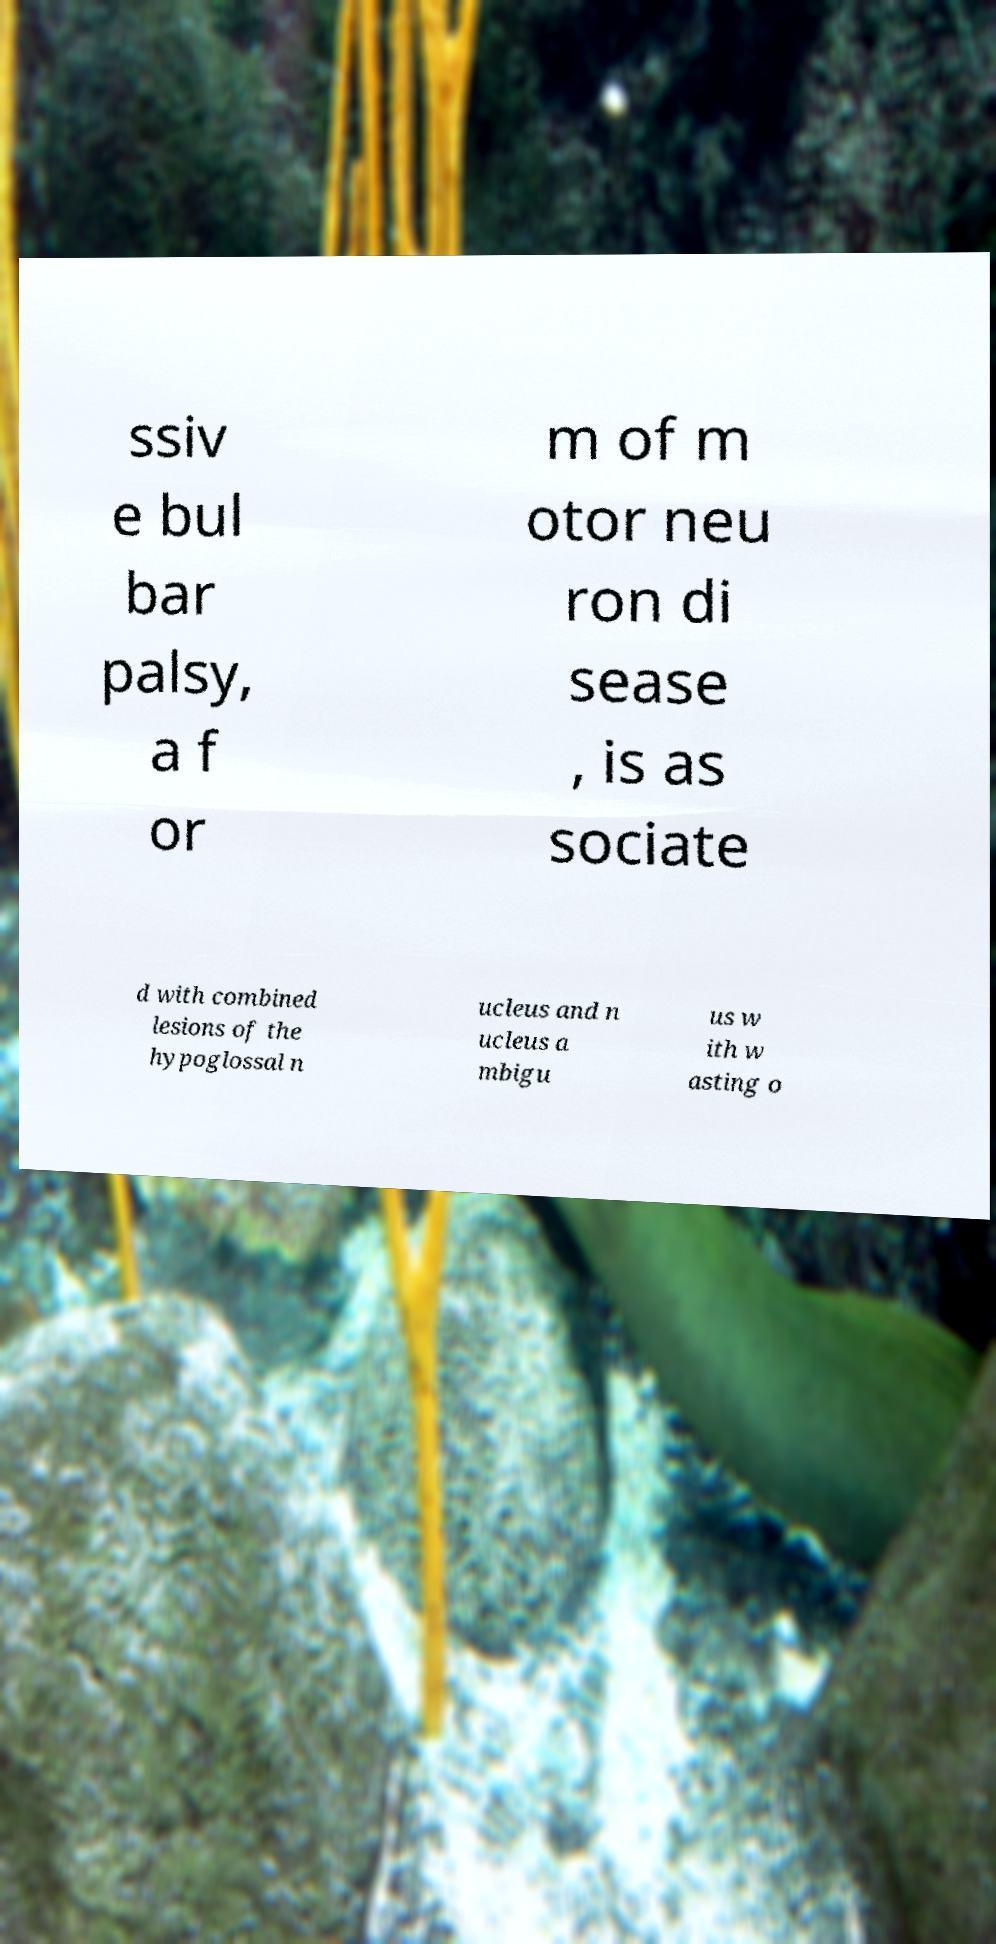Can you accurately transcribe the text from the provided image for me? ssiv e bul bar palsy, a f or m of m otor neu ron di sease , is as sociate d with combined lesions of the hypoglossal n ucleus and n ucleus a mbigu us w ith w asting o 